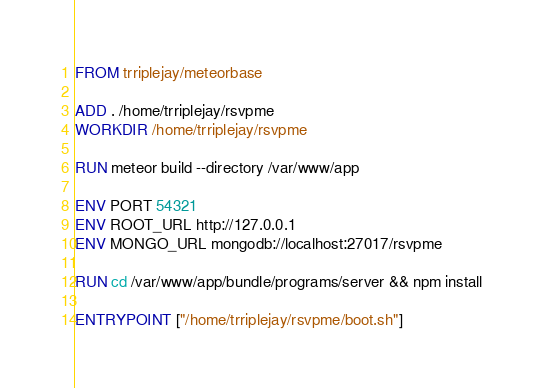Convert code to text. <code><loc_0><loc_0><loc_500><loc_500><_Dockerfile_>FROM trriplejay/meteorbase

ADD . /home/trriplejay/rsvpme
WORKDIR /home/trriplejay/rsvpme

RUN meteor build --directory /var/www/app

ENV PORT 54321 
ENV ROOT_URL http://127.0.0.1
ENV MONGO_URL mongodb://localhost:27017/rsvpme

RUN cd /var/www/app/bundle/programs/server && npm install

ENTRYPOINT ["/home/trriplejay/rsvpme/boot.sh"]

</code> 